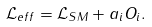<formula> <loc_0><loc_0><loc_500><loc_500>\mathcal { L } _ { e f f } = \mathcal { L } _ { S M } + a _ { i } O _ { i } .</formula> 